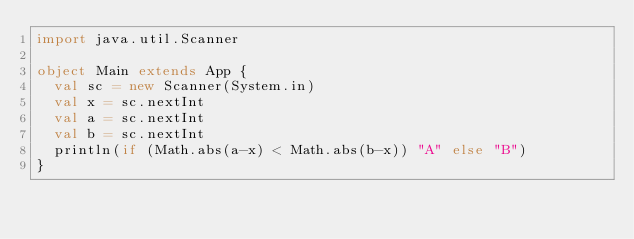Convert code to text. <code><loc_0><loc_0><loc_500><loc_500><_Scala_>import java.util.Scanner

object Main extends App {
  val sc = new Scanner(System.in)
  val x = sc.nextInt
  val a = sc.nextInt
  val b = sc.nextInt
  println(if (Math.abs(a-x) < Math.abs(b-x)) "A" else "B")
}</code> 